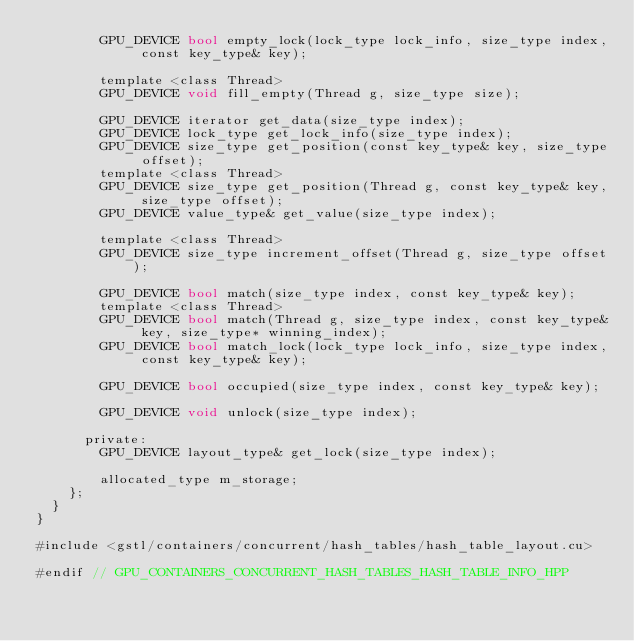<code> <loc_0><loc_0><loc_500><loc_500><_Cuda_>				GPU_DEVICE bool empty_lock(lock_type lock_info, size_type index, const key_type& key);

				template <class Thread>
				GPU_DEVICE void fill_empty(Thread g, size_type size);

				GPU_DEVICE iterator get_data(size_type index);
				GPU_DEVICE lock_type get_lock_info(size_type index);
				GPU_DEVICE size_type get_position(const key_type& key, size_type offset);
				template <class Thread>
				GPU_DEVICE size_type get_position(Thread g, const key_type& key, size_type offset);
				GPU_DEVICE value_type& get_value(size_type index);

				template <class Thread>
				GPU_DEVICE size_type increment_offset(Thread g, size_type offset);

				GPU_DEVICE bool match(size_type index, const key_type& key);
				template <class Thread>
				GPU_DEVICE bool match(Thread g, size_type index, const key_type& key, size_type* winning_index);
				GPU_DEVICE bool match_lock(lock_type lock_info, size_type index, const key_type& key);

				GPU_DEVICE bool occupied(size_type index, const key_type& key);

				GPU_DEVICE void unlock(size_type index);

			private:
				GPU_DEVICE layout_type& get_lock(size_type index);

				allocated_type m_storage;
		};
	}
}

#include <gstl/containers/concurrent/hash_tables/hash_table_layout.cu>

#endif // GPU_CONTAINERS_CONCURRENT_HASH_TABLES_HASH_TABLE_INFO_HPP
</code> 